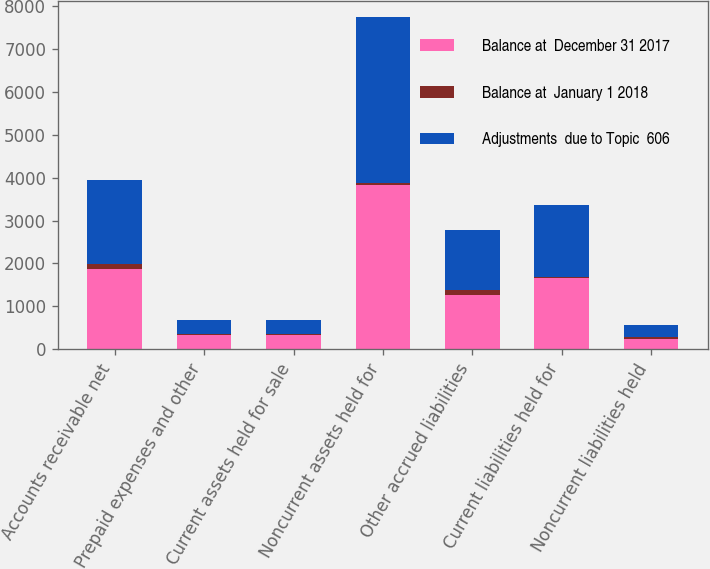Convert chart. <chart><loc_0><loc_0><loc_500><loc_500><stacked_bar_chart><ecel><fcel>Accounts receivable net<fcel>Prepaid expenses and other<fcel>Current assets held for sale<fcel>Noncurrent assets held for<fcel>Other accrued liabilities<fcel>Current liabilities held for<fcel>Noncurrent liabilities held<nl><fcel>Balance at  December 31 2017<fcel>1879.3<fcel>327.9<fcel>327.9<fcel>3842.2<fcel>1271.9<fcel>1661.3<fcel>242.5<nl><fcel>Balance at  January 1 2018<fcel>100.3<fcel>14.6<fcel>21.3<fcel>33.8<fcel>114.9<fcel>21.3<fcel>33.8<nl><fcel>Adjustments  due to Topic  606<fcel>1979.6<fcel>342.5<fcel>327.9<fcel>3876<fcel>1386.8<fcel>1682.6<fcel>276.3<nl></chart> 